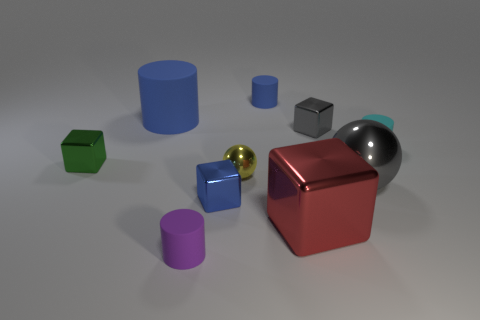Subtract all big red metallic cubes. How many cubes are left? 3 Add 1 tiny yellow metal spheres. How many tiny yellow metal spheres are left? 2 Add 6 large gray shiny spheres. How many large gray shiny spheres exist? 7 Subtract all gray balls. How many balls are left? 1 Subtract 1 gray cubes. How many objects are left? 9 Subtract all cylinders. How many objects are left? 6 Subtract 4 cubes. How many cubes are left? 0 Subtract all blue cubes. Subtract all cyan spheres. How many cubes are left? 3 Subtract all red cubes. How many purple cylinders are left? 1 Subtract all large matte cylinders. Subtract all yellow metal balls. How many objects are left? 8 